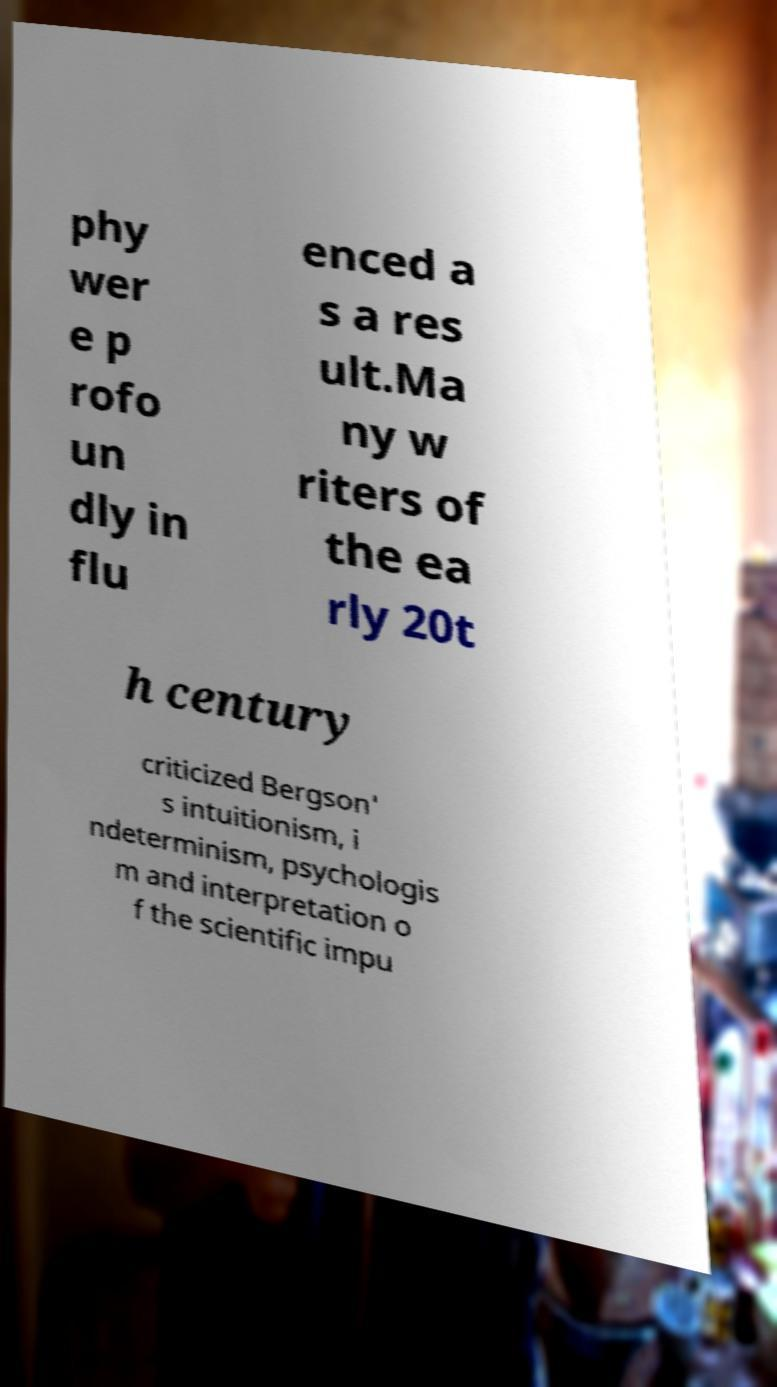Please identify and transcribe the text found in this image. phy wer e p rofo un dly in flu enced a s a res ult.Ma ny w riters of the ea rly 20t h century criticized Bergson' s intuitionism, i ndeterminism, psychologis m and interpretation o f the scientific impu 